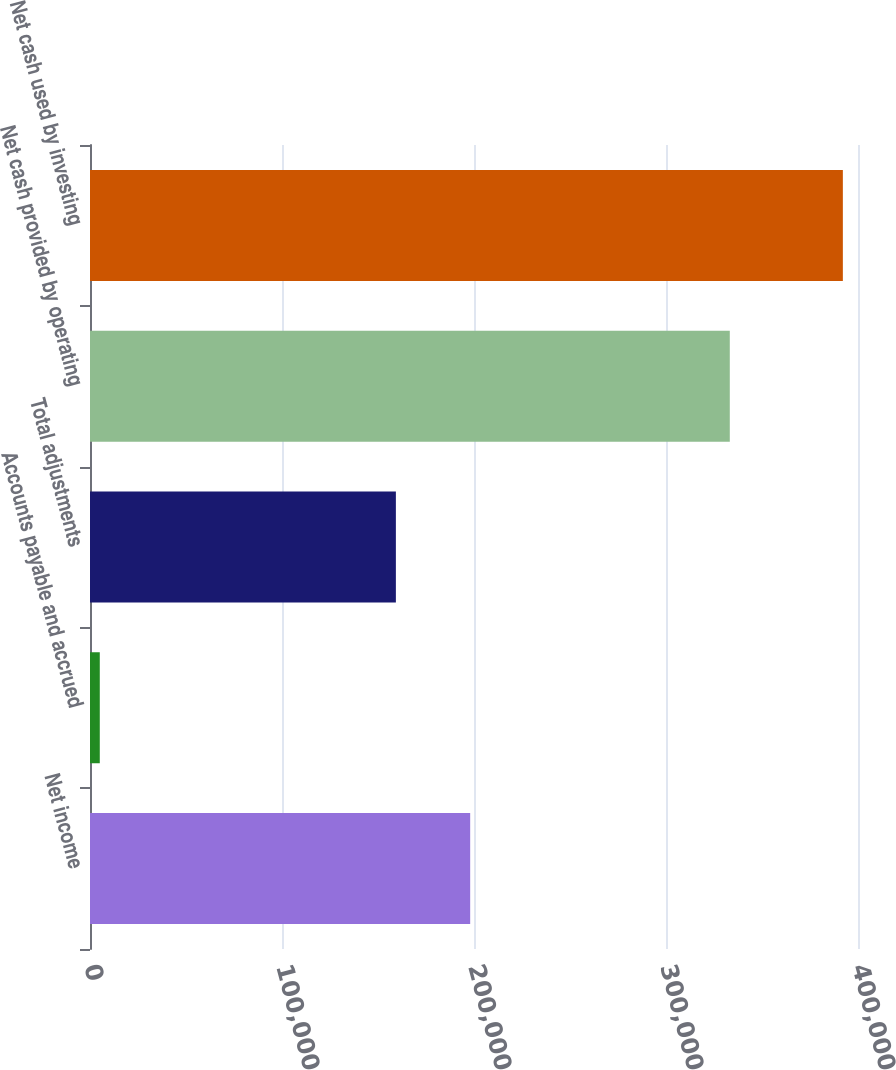<chart> <loc_0><loc_0><loc_500><loc_500><bar_chart><fcel>Net income<fcel>Accounts payable and accrued<fcel>Total adjustments<fcel>Net cash provided by operating<fcel>Net cash used by investing<nl><fcel>198013<fcel>5096<fcel>159311<fcel>333227<fcel>392113<nl></chart> 